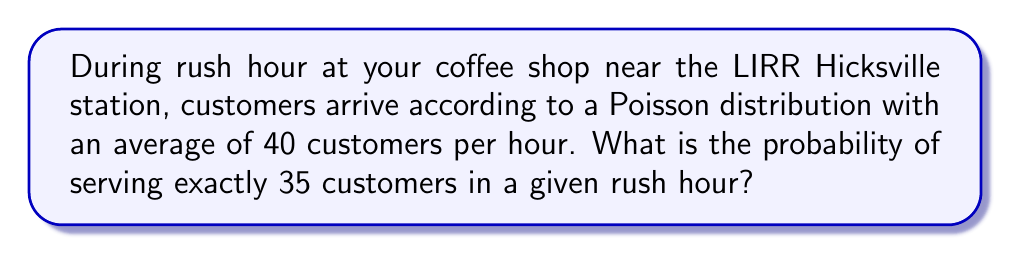Help me with this question. Let's approach this step-by-step:

1) The Poisson distribution is used to model the number of events occurring in a fixed interval of time when these events occur with a known average rate.

2) The probability mass function for a Poisson distribution is:

   $$P(X = k) = \frac{e^{-\lambda}\lambda^k}{k!}$$

   where:
   - $\lambda$ is the average number of events per interval
   - $k$ is the number of events we're calculating the probability for
   - $e$ is Euler's number (approximately 2.71828)

3) In this case:
   - $\lambda = 40$ (average customers per hour)
   - $k = 35$ (we're calculating the probability of exactly 35 customers)

4) Let's substitute these values into the formula:

   $$P(X = 35) = \frac{e^{-40}40^{35}}{35!}$$

5) Now, let's calculate this step-by-step:
   - $e^{-40} \approx 4.2484 \times 10^{-18}$
   - $40^{35} \approx 2.8147 \times 10^{57}$
   - $35! \approx 1.0333 \times 10^{40}$

6) Putting it all together:

   $$P(X = 35) = \frac{4.2484 \times 10^{-18} \times 2.8147 \times 10^{57}}{1.0333 \times 10^{40}} \approx 0.0456$$

7) Therefore, the probability of serving exactly 35 customers in a given rush hour is approximately 0.0456 or 4.56%.
Answer: $0.0456$ or $4.56\%$ 